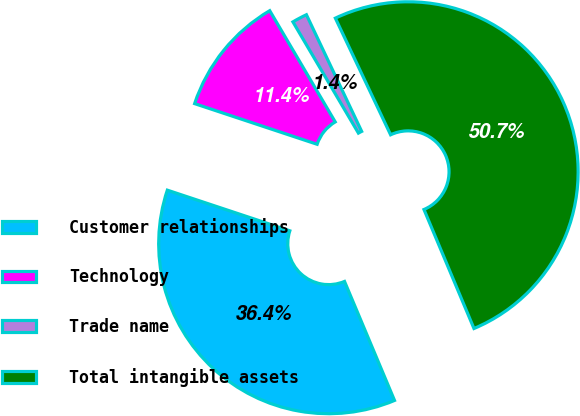Convert chart. <chart><loc_0><loc_0><loc_500><loc_500><pie_chart><fcel>Customer relationships<fcel>Technology<fcel>Trade name<fcel>Total intangible assets<nl><fcel>36.43%<fcel>11.43%<fcel>1.43%<fcel>50.71%<nl></chart> 